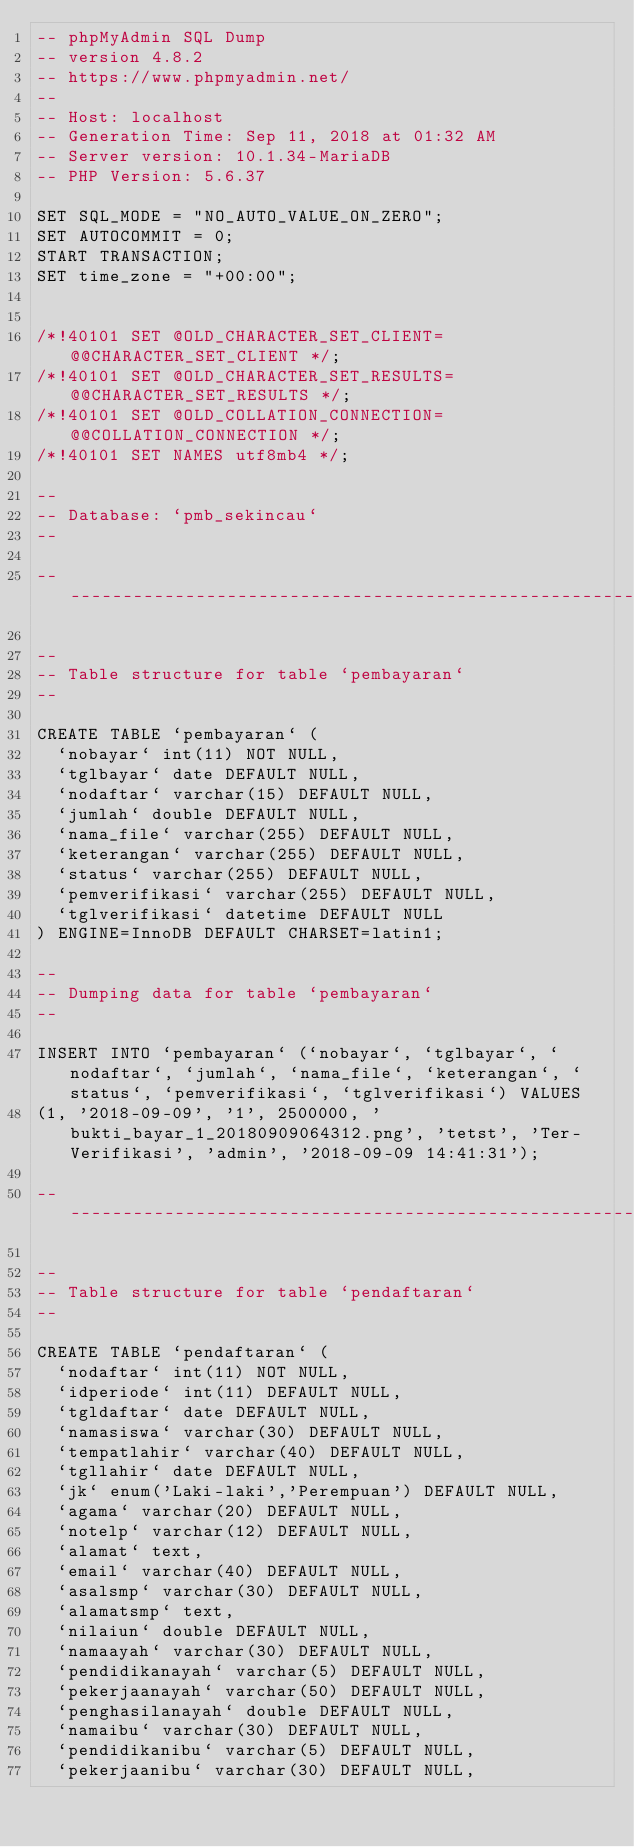Convert code to text. <code><loc_0><loc_0><loc_500><loc_500><_SQL_>-- phpMyAdmin SQL Dump
-- version 4.8.2
-- https://www.phpmyadmin.net/
--
-- Host: localhost
-- Generation Time: Sep 11, 2018 at 01:32 AM
-- Server version: 10.1.34-MariaDB
-- PHP Version: 5.6.37

SET SQL_MODE = "NO_AUTO_VALUE_ON_ZERO";
SET AUTOCOMMIT = 0;
START TRANSACTION;
SET time_zone = "+00:00";


/*!40101 SET @OLD_CHARACTER_SET_CLIENT=@@CHARACTER_SET_CLIENT */;
/*!40101 SET @OLD_CHARACTER_SET_RESULTS=@@CHARACTER_SET_RESULTS */;
/*!40101 SET @OLD_COLLATION_CONNECTION=@@COLLATION_CONNECTION */;
/*!40101 SET NAMES utf8mb4 */;

--
-- Database: `pmb_sekincau`
--

-- --------------------------------------------------------

--
-- Table structure for table `pembayaran`
--

CREATE TABLE `pembayaran` (
  `nobayar` int(11) NOT NULL,
  `tglbayar` date DEFAULT NULL,
  `nodaftar` varchar(15) DEFAULT NULL,
  `jumlah` double DEFAULT NULL,
  `nama_file` varchar(255) DEFAULT NULL,
  `keterangan` varchar(255) DEFAULT NULL,
  `status` varchar(255) DEFAULT NULL,
  `pemverifikasi` varchar(255) DEFAULT NULL,
  `tglverifikasi` datetime DEFAULT NULL
) ENGINE=InnoDB DEFAULT CHARSET=latin1;

--
-- Dumping data for table `pembayaran`
--

INSERT INTO `pembayaran` (`nobayar`, `tglbayar`, `nodaftar`, `jumlah`, `nama_file`, `keterangan`, `status`, `pemverifikasi`, `tglverifikasi`) VALUES
(1, '2018-09-09', '1', 2500000, 'bukti_bayar_1_20180909064312.png', 'tetst', 'Ter-Verifikasi', 'admin', '2018-09-09 14:41:31');

-- --------------------------------------------------------

--
-- Table structure for table `pendaftaran`
--

CREATE TABLE `pendaftaran` (
  `nodaftar` int(11) NOT NULL,
  `idperiode` int(11) DEFAULT NULL,
  `tgldaftar` date DEFAULT NULL,
  `namasiswa` varchar(30) DEFAULT NULL,
  `tempatlahir` varchar(40) DEFAULT NULL,
  `tgllahir` date DEFAULT NULL,
  `jk` enum('Laki-laki','Perempuan') DEFAULT NULL,
  `agama` varchar(20) DEFAULT NULL,
  `notelp` varchar(12) DEFAULT NULL,
  `alamat` text,
  `email` varchar(40) DEFAULT NULL,
  `asalsmp` varchar(30) DEFAULT NULL,
  `alamatsmp` text,
  `nilaiun` double DEFAULT NULL,
  `namaayah` varchar(30) DEFAULT NULL,
  `pendidikanayah` varchar(5) DEFAULT NULL,
  `pekerjaanayah` varchar(50) DEFAULT NULL,
  `penghasilanayah` double DEFAULT NULL,
  `namaibu` varchar(30) DEFAULT NULL,
  `pendidikanibu` varchar(5) DEFAULT NULL,
  `pekerjaanibu` varchar(30) DEFAULT NULL,</code> 